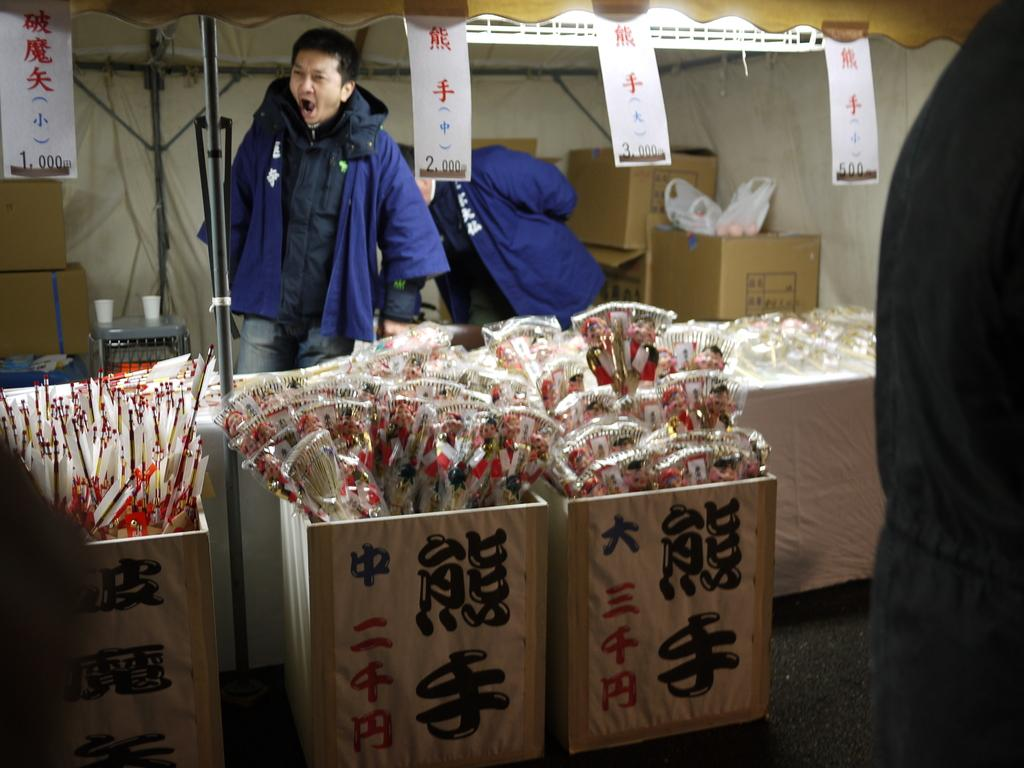Who is present in the image? There is a man in the image. What is the man wearing? The man is wearing a blue jacket. What objects can be seen in the image besides the man? There are boxes, a white wall, a stool, two glasses, and banners in the image. What is the stool being used for in the image? The stool is being used to hold two glasses. Can you see a hydrant in the image? No, there is no hydrant present in the image. What direction is the man facing in the image? The provided facts do not mention the man's facing direction, so it cannot be determined from the image. 